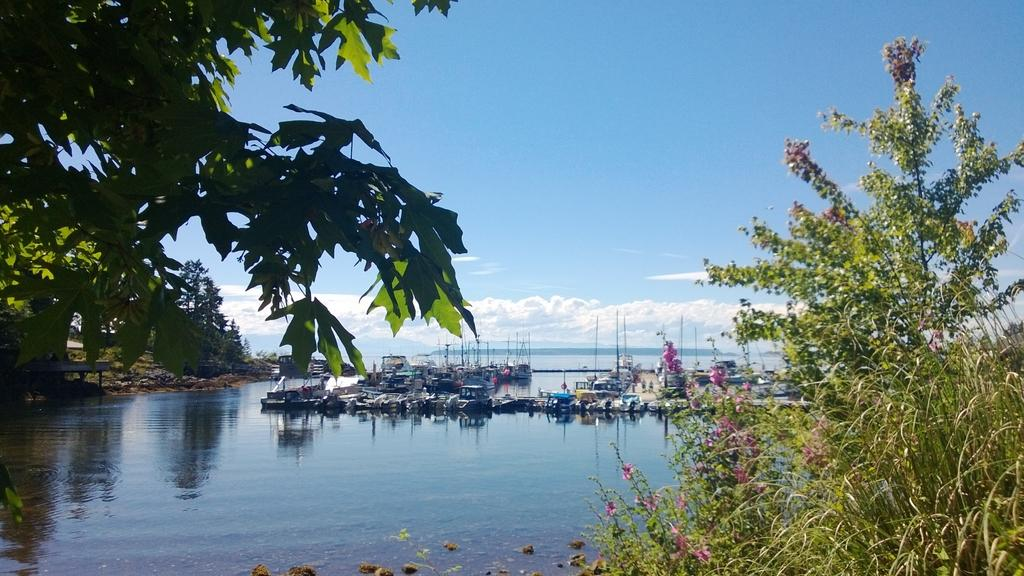What type of location is depicted in the image? There is a shipyard in the image. Where is the shipyard situated? The shipyard is located on the water. What type of vegetation can be seen in the image? There are trees in the image. Are there any plants with colorful blooms in the image? Yes, there are flowers in the image. How would you describe the weather based on the image? The sky is cloudy in the image. Can you see a wrench being used to fix a toy in the image? There is no wrench or toy present in the image; it features a shipyard located on the water. What type of clover is growing near the flowers in the image? There is no clover present in the image; only trees and flowers are visible. 